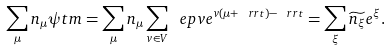<formula> <loc_0><loc_0><loc_500><loc_500>\sum _ { \mu } n _ { \mu } \psi t m = \sum _ { \mu } n _ { \mu } \sum _ { v \in V } \ e p v e ^ { v ( \mu + \ r r t ) - \ r r t } = \sum _ { \xi } \widetilde { n _ { \xi } } e ^ { \xi } .</formula> 